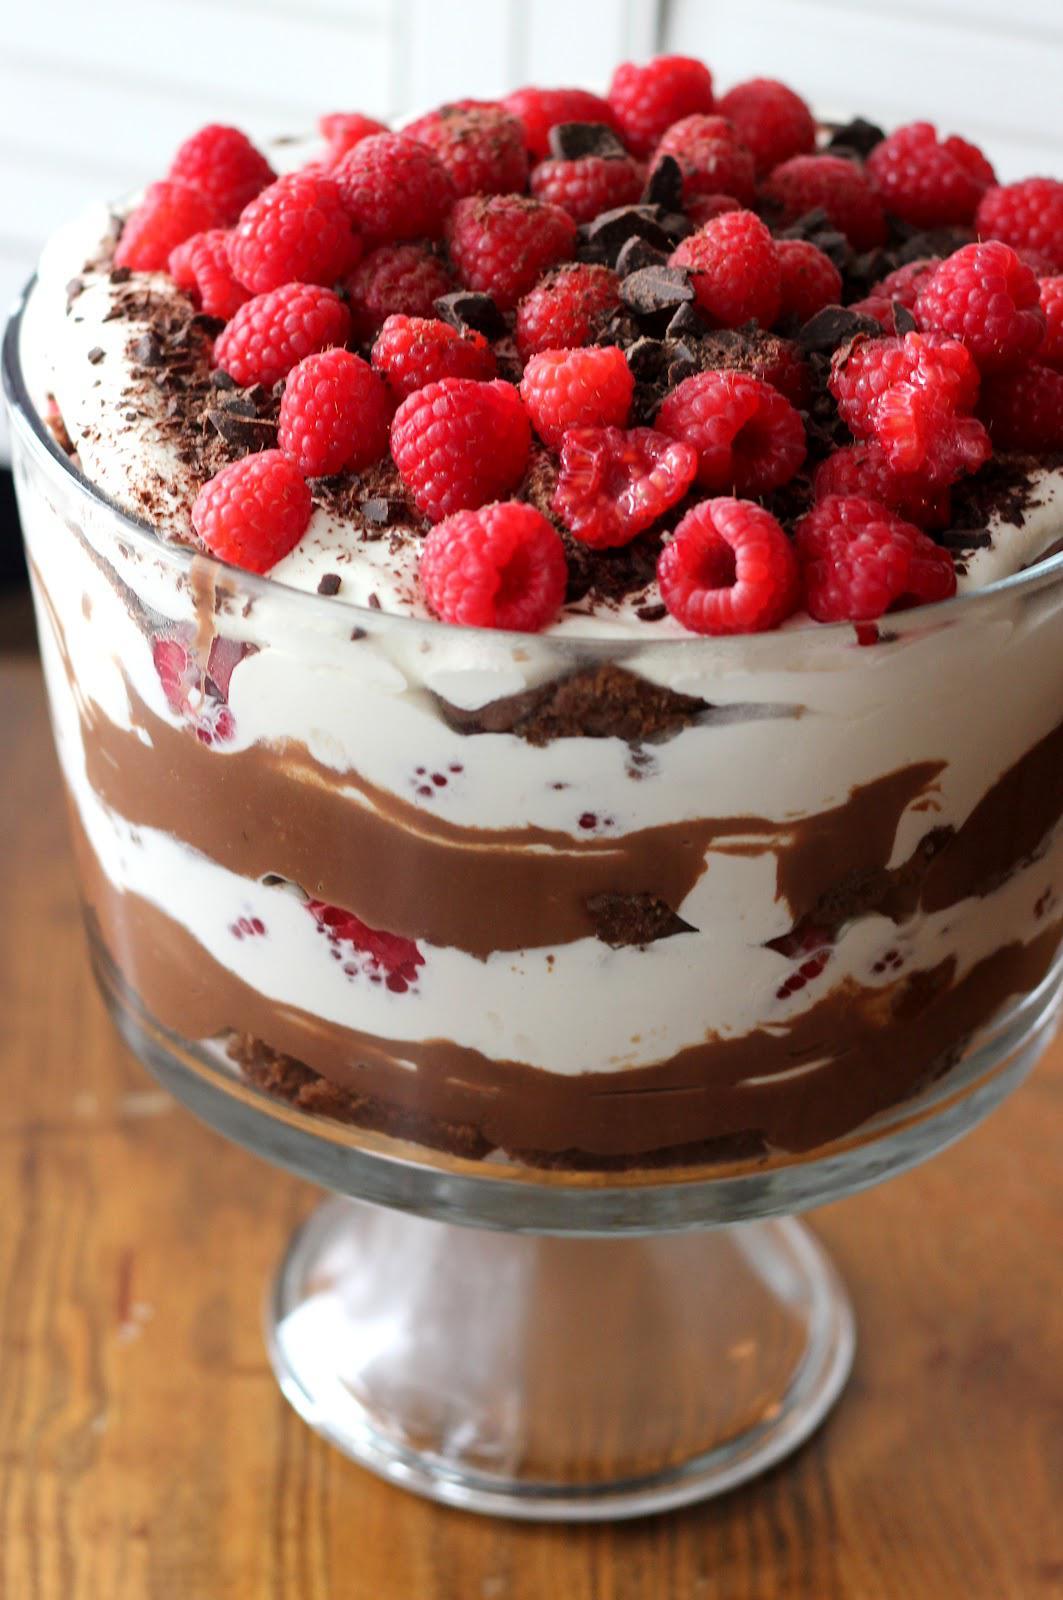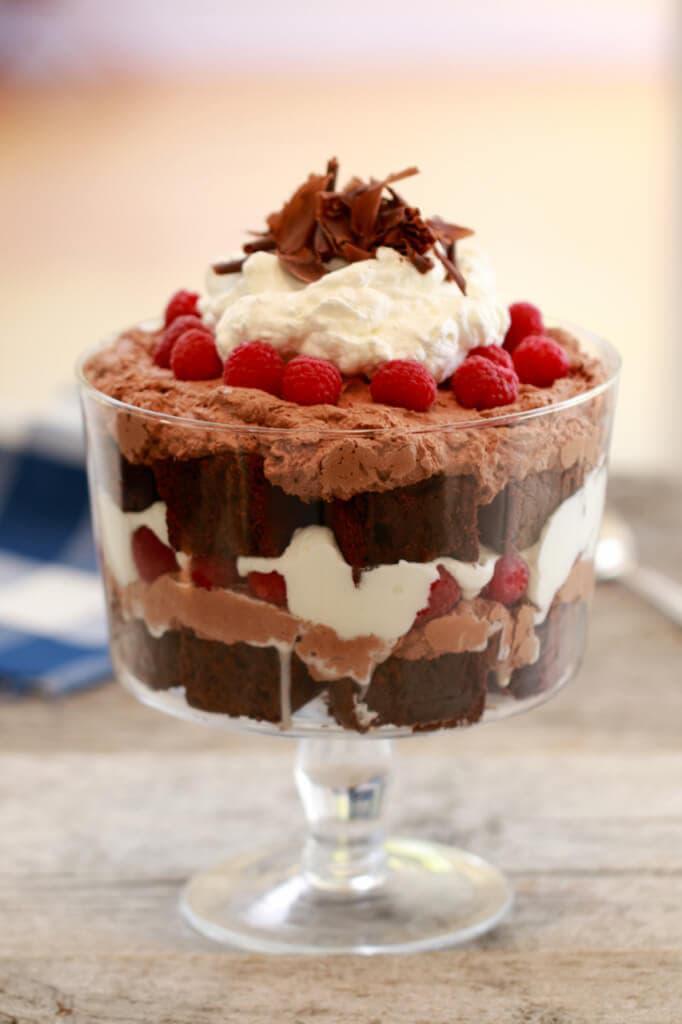The first image is the image on the left, the second image is the image on the right. For the images shown, is this caption "An image shows one large dessert in a footed glass, garnished with raspberries on top and not any form of chocolate." true? Answer yes or no. No. The first image is the image on the left, the second image is the image on the right. For the images shown, is this caption "There is a silver utensil next to a trifle." true? Answer yes or no. No. 